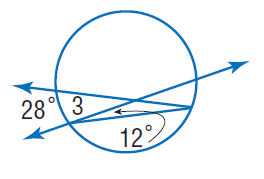Question: Find the measure of m \angle 3. Assume that segments that appear tangent are tangent.
Choices:
A. 12
B. 20
C. 26
D. 28
Answer with the letter. Answer: C 